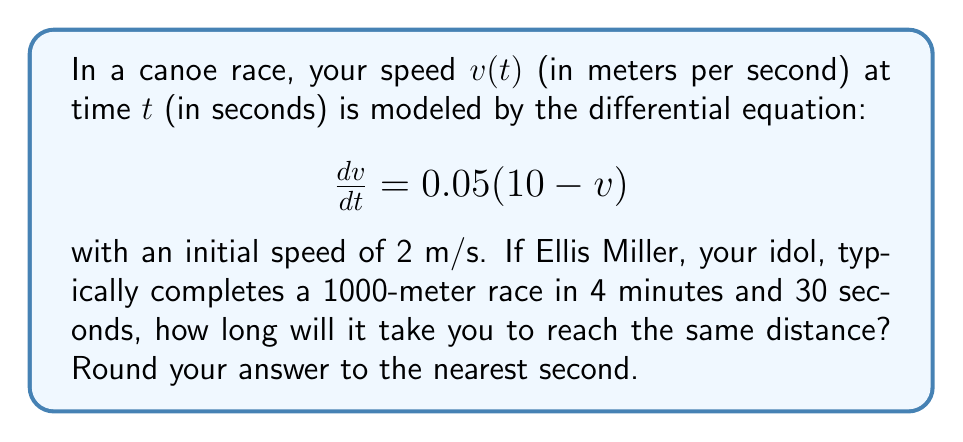Teach me how to tackle this problem. Let's approach this step-by-step:

1) First, we need to solve the differential equation. This is a first-order linear differential equation.

2) The general solution to this equation is:
   $$v(t) = 10 - 8e^{-0.05t}$$

3) Now, we need to find the distance traveled. Distance is the integral of velocity over time:
   $$x(t) = \int_0^t v(s) ds = \int_0^t (10 - 8e^{-0.05s}) ds$$

4) Integrating this:
   $$x(t) = 10t + 160(1 - e^{-0.05t})$$

5) We want to find $t$ when $x(t) = 1000$. So we need to solve:
   $$1000 = 10t + 160(1 - e^{-0.05t})$$

6) This equation can't be solved algebraically. We need to use numerical methods.

7) Using a numerical solver (like Newton's method), we find that $t \approx 106.3$ seconds.

8) Rounding to the nearest second, we get 106 seconds.

9) Converting to minutes and seconds: 1 minute and 46 seconds.

10) Comparing to Ellis Miller's time of 4 minutes and 30 seconds, you're significantly faster in this model!
Answer: 1 minute and 46 seconds (106 seconds) 